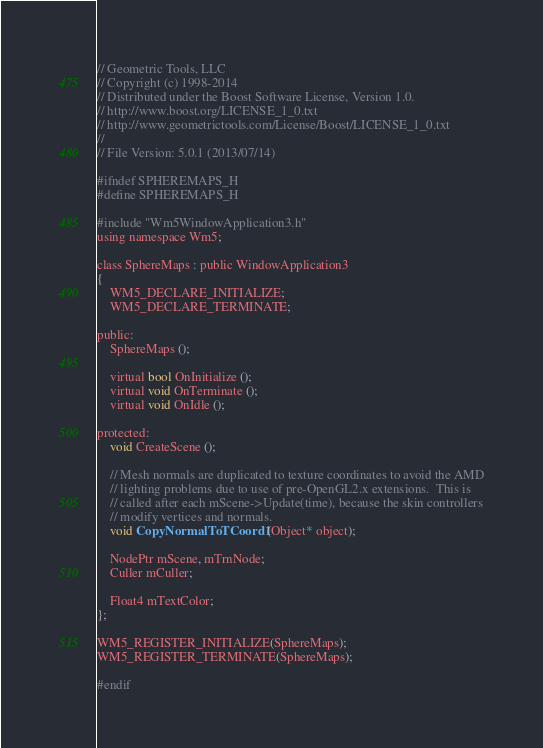Convert code to text. <code><loc_0><loc_0><loc_500><loc_500><_C_>// Geometric Tools, LLC
// Copyright (c) 1998-2014
// Distributed under the Boost Software License, Version 1.0.
// http://www.boost.org/LICENSE_1_0.txt
// http://www.geometrictools.com/License/Boost/LICENSE_1_0.txt
//
// File Version: 5.0.1 (2013/07/14)

#ifndef SPHEREMAPS_H
#define SPHEREMAPS_H

#include "Wm5WindowApplication3.h"
using namespace Wm5;

class SphereMaps : public WindowApplication3
{
    WM5_DECLARE_INITIALIZE;
    WM5_DECLARE_TERMINATE;

public:
    SphereMaps ();

    virtual bool OnInitialize ();
    virtual void OnTerminate ();
    virtual void OnIdle ();

protected:
    void CreateScene ();

    // Mesh normals are duplicated to texture coordinates to avoid the AMD
    // lighting problems due to use of pre-OpenGL2.x extensions.  This is
    // called after each mScene->Update(time), because the skin controllers
    // modify vertices and normals.
    void CopyNormalToTCoord1 (Object* object);

    NodePtr mScene, mTrnNode;
    Culler mCuller;

    Float4 mTextColor;
};

WM5_REGISTER_INITIALIZE(SphereMaps);
WM5_REGISTER_TERMINATE(SphereMaps);

#endif
</code> 